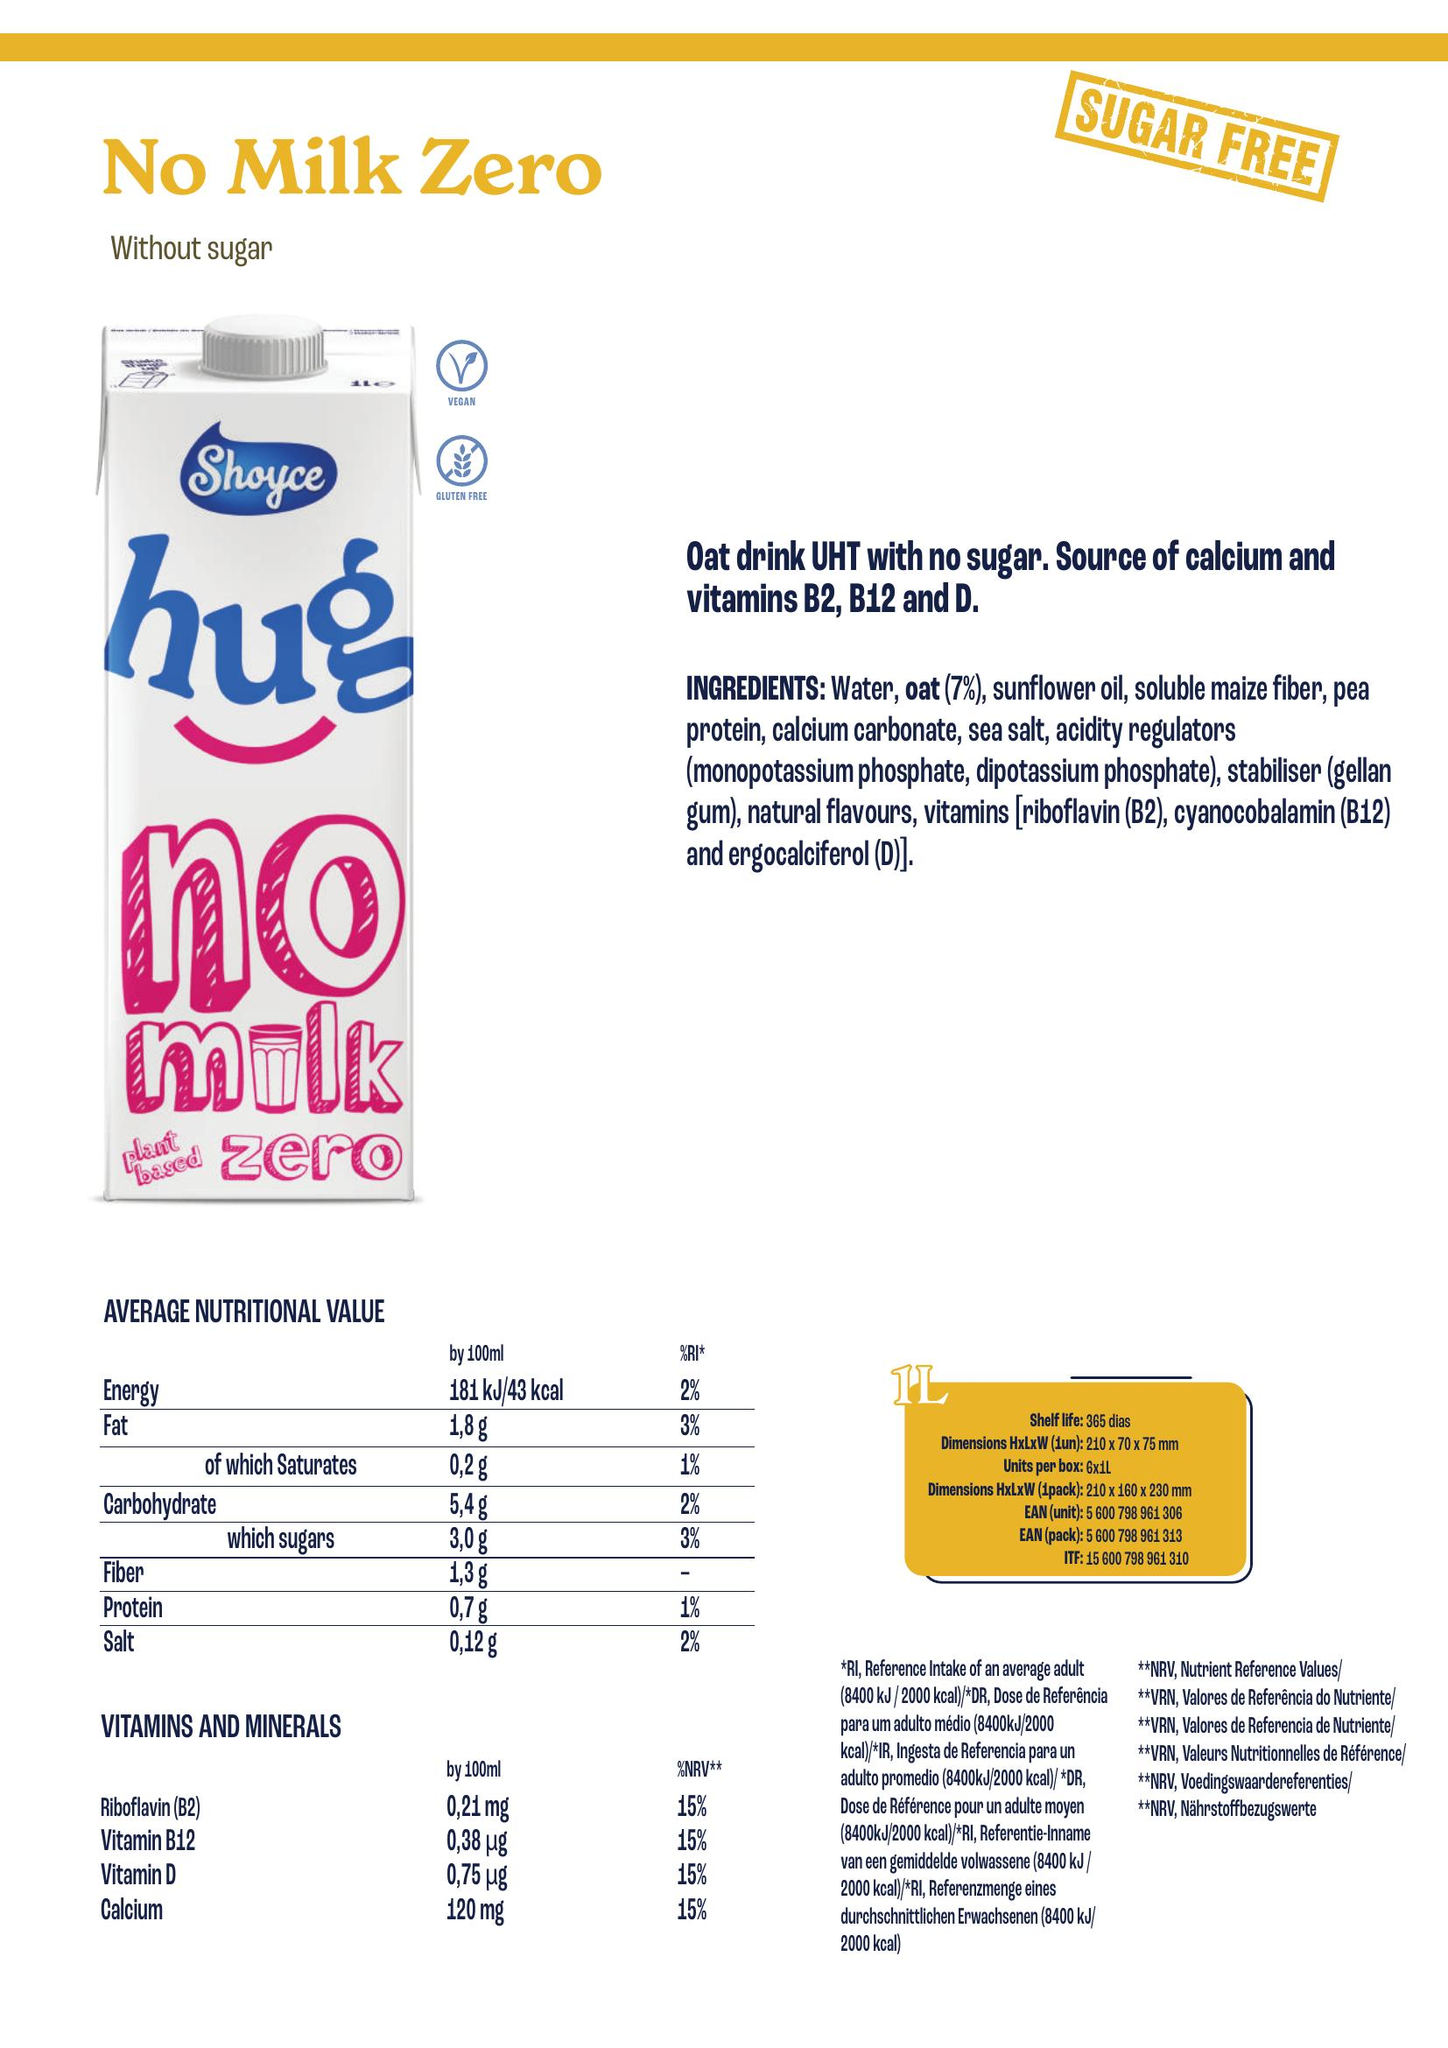From the image, create a nutrition table include as columns the different nutrient present, add the unit associated with the nutrient and append the volume considered for the values in [] after the nutrient name, for energy only consider the information for kcal and isolate the associate value accordingly. Add a column for the product name located in the top left, add a column for the ingredients associated with the product, also add a column for allergens which are ingredients in bold listed in the ingredients.  Write the result as python code to build a dataframe
 Below is the Python code to build a pandas DataFrame with the nutrition table from the image provided:

```python
import pandas as pd

# Define the data for the nutrition table as a dictionary
nutrition_data = {
    'Product Name': ['No Milk Zero'],
    'Energy [kcal]': [43],
    'Fat [g]': [1.8],
    'of which Saturates [g]': [0.2],
    'Carbohydrate [g]': [5.4],
    'of which sugars [g]': [3.0],
    'Fiber [g]': [1.3],
    'Protein [g]': [0.7],
    'Salt [g]': [0.12],
    'Riboflavin (B2) [mg]': [0.21],
    'Vitamin B12 [µg]': [0.38],
    'Vitamin D [µg]': [0.75],
    'Calcium [mg]': [120],
    'Ingredients': ['Water, oat (7%), sunflower oil, soluble maize fiber, pea protein, calcium carbonate, sea salt, acidity regulators (monopotassium phosphate, dipotassium phosphate), stabiliser (gellan gum), natural flavours, vitamins (riboflavin (B2), cyanocobalamin (B12) and ergocalciferol (D))'],
    'Allergens': ['oat']
}

# Create the DataFrame
nutrition_df = pd.DataFrame(nutrition_data)

# Display the DataFrame
print(nutrition_df)
```

This code snippet creates a DataFrame with the nutritional values taken from the image of the product "No Milk Zero". It also includes the product name, ingredients, and allergens as specified. The allergens are listed as bold in the ingredients, which, in this case, is "oat". Please note that this DataFrame represents the values per 100 ml as shown in the image. 